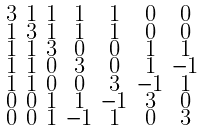<formula> <loc_0><loc_0><loc_500><loc_500>\begin{smallmatrix} 3 & 1 & 1 & 1 & 1 & 0 & 0 \\ 1 & 3 & 1 & 1 & 1 & 0 & 0 \\ 1 & 1 & 3 & 0 & 0 & 1 & 1 \\ 1 & 1 & 0 & 3 & 0 & 1 & - 1 \\ 1 & 1 & 0 & 0 & 3 & - 1 & 1 \\ 0 & 0 & 1 & 1 & - 1 & 3 & 0 \\ 0 & 0 & 1 & - 1 & 1 & 0 & 3 \end{smallmatrix}</formula> 